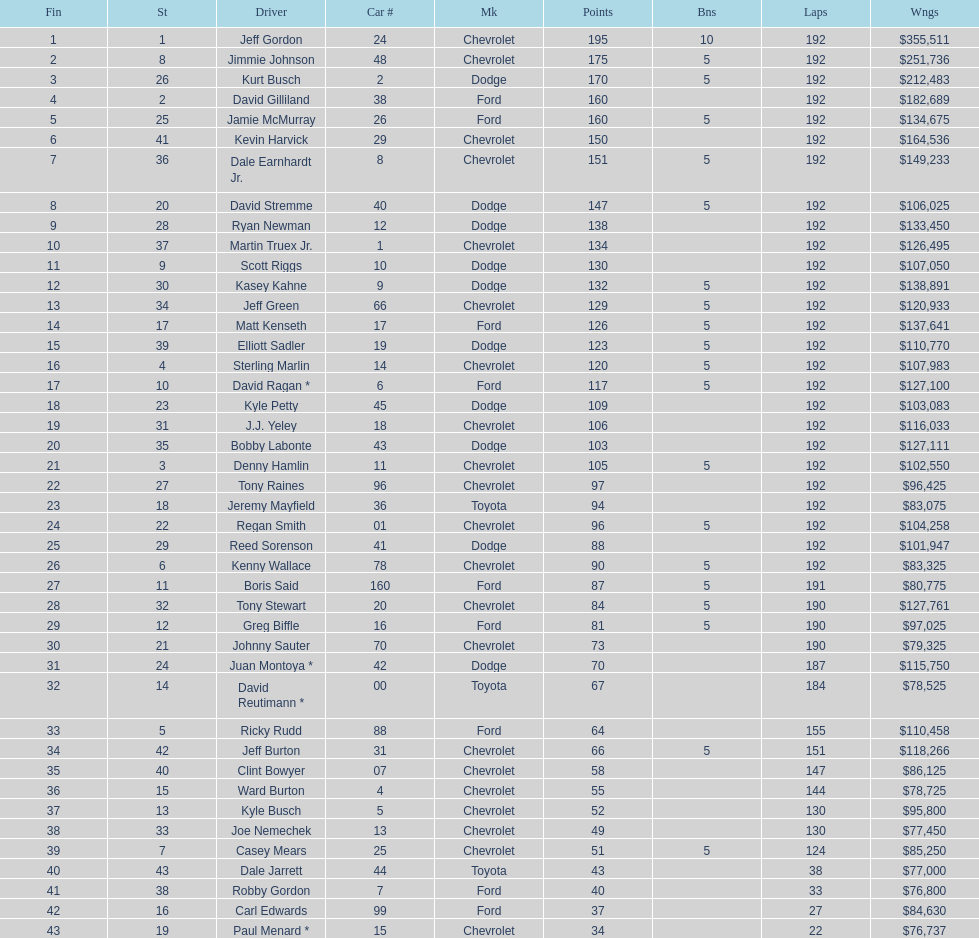How many drivers earned 5 bonus each in the race? 19. 